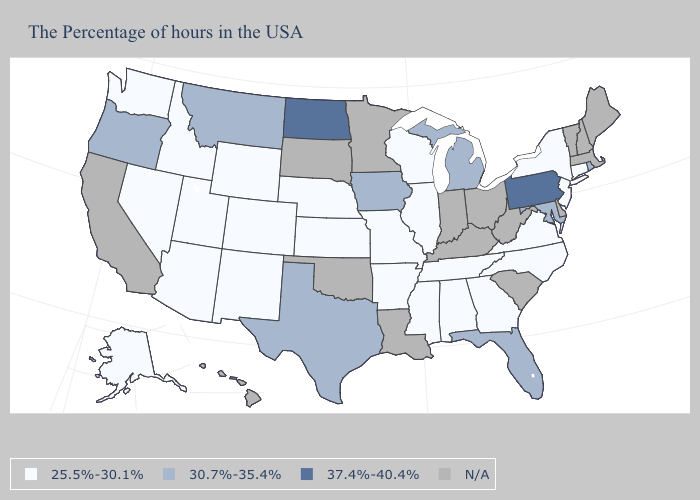Is the legend a continuous bar?
Be succinct. No. What is the highest value in the MidWest ?
Quick response, please. 37.4%-40.4%. Does Kansas have the highest value in the MidWest?
Write a very short answer. No. What is the value of Georgia?
Give a very brief answer. 25.5%-30.1%. Does Virginia have the lowest value in the USA?
Short answer required. Yes. What is the value of Michigan?
Be succinct. 30.7%-35.4%. Name the states that have a value in the range 30.7%-35.4%?
Give a very brief answer. Rhode Island, Maryland, Florida, Michigan, Iowa, Texas, Montana, Oregon. Which states hav the highest value in the West?
Write a very short answer. Montana, Oregon. Name the states that have a value in the range 25.5%-30.1%?
Quick response, please. Connecticut, New York, New Jersey, Virginia, North Carolina, Georgia, Alabama, Tennessee, Wisconsin, Illinois, Mississippi, Missouri, Arkansas, Kansas, Nebraska, Wyoming, Colorado, New Mexico, Utah, Arizona, Idaho, Nevada, Washington, Alaska. What is the highest value in states that border Idaho?
Concise answer only. 30.7%-35.4%. Name the states that have a value in the range N/A?
Be succinct. Maine, Massachusetts, New Hampshire, Vermont, Delaware, South Carolina, West Virginia, Ohio, Kentucky, Indiana, Louisiana, Minnesota, Oklahoma, South Dakota, California, Hawaii. What is the highest value in the USA?
Keep it brief. 37.4%-40.4%. What is the value of Maryland?
Short answer required. 30.7%-35.4%. What is the value of Georgia?
Write a very short answer. 25.5%-30.1%. 